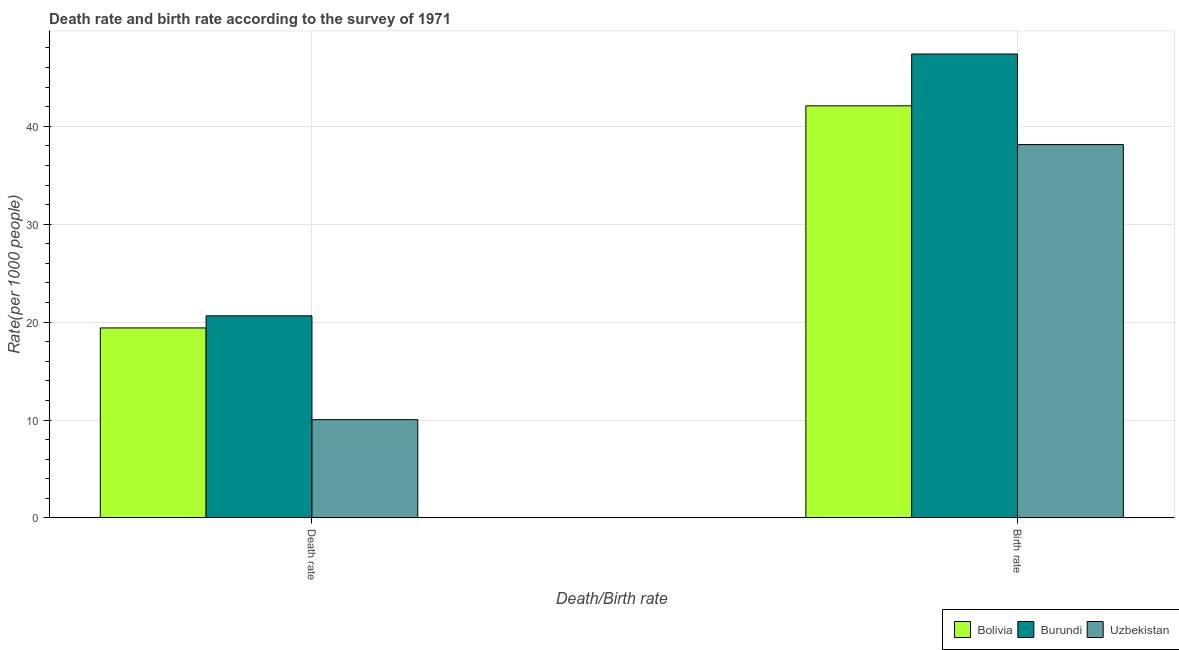Are the number of bars per tick equal to the number of legend labels?
Make the answer very short. Yes. Are the number of bars on each tick of the X-axis equal?
Your response must be concise. Yes. What is the label of the 1st group of bars from the left?
Offer a terse response. Death rate. What is the death rate in Burundi?
Give a very brief answer. 20.64. Across all countries, what is the maximum death rate?
Your response must be concise. 20.64. Across all countries, what is the minimum death rate?
Your response must be concise. 10.03. In which country was the death rate maximum?
Make the answer very short. Burundi. In which country was the birth rate minimum?
Keep it short and to the point. Uzbekistan. What is the total birth rate in the graph?
Your answer should be compact. 127.61. What is the difference between the birth rate in Bolivia and that in Burundi?
Your response must be concise. -5.29. What is the difference between the death rate in Bolivia and the birth rate in Uzbekistan?
Provide a short and direct response. -18.73. What is the average death rate per country?
Provide a short and direct response. 16.69. What is the difference between the birth rate and death rate in Burundi?
Offer a terse response. 26.74. In how many countries, is the birth rate greater than 18 ?
Offer a terse response. 3. What is the ratio of the birth rate in Uzbekistan to that in Burundi?
Provide a succinct answer. 0.8. In how many countries, is the death rate greater than the average death rate taken over all countries?
Your answer should be very brief. 2. What does the 3rd bar from the left in Birth rate represents?
Offer a terse response. Uzbekistan. What does the 1st bar from the right in Death rate represents?
Make the answer very short. Uzbekistan. How many bars are there?
Make the answer very short. 6. Are all the bars in the graph horizontal?
Offer a terse response. No. Does the graph contain grids?
Make the answer very short. Yes. Where does the legend appear in the graph?
Ensure brevity in your answer.  Bottom right. What is the title of the graph?
Give a very brief answer. Death rate and birth rate according to the survey of 1971. Does "St. Martin (French part)" appear as one of the legend labels in the graph?
Make the answer very short. No. What is the label or title of the X-axis?
Your answer should be compact. Death/Birth rate. What is the label or title of the Y-axis?
Offer a terse response. Rate(per 1000 people). What is the Rate(per 1000 people) in Bolivia in Death rate?
Your answer should be compact. 19.41. What is the Rate(per 1000 people) of Burundi in Death rate?
Keep it short and to the point. 20.64. What is the Rate(per 1000 people) in Uzbekistan in Death rate?
Keep it short and to the point. 10.03. What is the Rate(per 1000 people) of Bolivia in Birth rate?
Offer a terse response. 42.09. What is the Rate(per 1000 people) in Burundi in Birth rate?
Provide a succinct answer. 47.38. What is the Rate(per 1000 people) in Uzbekistan in Birth rate?
Offer a very short reply. 38.13. Across all Death/Birth rate, what is the maximum Rate(per 1000 people) in Bolivia?
Make the answer very short. 42.09. Across all Death/Birth rate, what is the maximum Rate(per 1000 people) in Burundi?
Ensure brevity in your answer.  47.38. Across all Death/Birth rate, what is the maximum Rate(per 1000 people) in Uzbekistan?
Your answer should be compact. 38.13. Across all Death/Birth rate, what is the minimum Rate(per 1000 people) of Bolivia?
Provide a succinct answer. 19.41. Across all Death/Birth rate, what is the minimum Rate(per 1000 people) of Burundi?
Offer a terse response. 20.64. Across all Death/Birth rate, what is the minimum Rate(per 1000 people) of Uzbekistan?
Keep it short and to the point. 10.03. What is the total Rate(per 1000 people) in Bolivia in the graph?
Ensure brevity in your answer.  61.5. What is the total Rate(per 1000 people) in Burundi in the graph?
Make the answer very short. 68.03. What is the total Rate(per 1000 people) in Uzbekistan in the graph?
Your answer should be compact. 48.16. What is the difference between the Rate(per 1000 people) of Bolivia in Death rate and that in Birth rate?
Make the answer very short. -22.69. What is the difference between the Rate(per 1000 people) in Burundi in Death rate and that in Birth rate?
Offer a very short reply. -26.74. What is the difference between the Rate(per 1000 people) of Uzbekistan in Death rate and that in Birth rate?
Your answer should be compact. -28.1. What is the difference between the Rate(per 1000 people) in Bolivia in Death rate and the Rate(per 1000 people) in Burundi in Birth rate?
Offer a terse response. -27.98. What is the difference between the Rate(per 1000 people) in Bolivia in Death rate and the Rate(per 1000 people) in Uzbekistan in Birth rate?
Offer a terse response. -18.73. What is the difference between the Rate(per 1000 people) of Burundi in Death rate and the Rate(per 1000 people) of Uzbekistan in Birth rate?
Give a very brief answer. -17.49. What is the average Rate(per 1000 people) in Bolivia per Death/Birth rate?
Provide a short and direct response. 30.75. What is the average Rate(per 1000 people) of Burundi per Death/Birth rate?
Ensure brevity in your answer.  34.01. What is the average Rate(per 1000 people) in Uzbekistan per Death/Birth rate?
Provide a short and direct response. 24.08. What is the difference between the Rate(per 1000 people) in Bolivia and Rate(per 1000 people) in Burundi in Death rate?
Offer a very short reply. -1.24. What is the difference between the Rate(per 1000 people) of Bolivia and Rate(per 1000 people) of Uzbekistan in Death rate?
Give a very brief answer. 9.37. What is the difference between the Rate(per 1000 people) of Burundi and Rate(per 1000 people) of Uzbekistan in Death rate?
Your answer should be very brief. 10.61. What is the difference between the Rate(per 1000 people) in Bolivia and Rate(per 1000 people) in Burundi in Birth rate?
Your response must be concise. -5.29. What is the difference between the Rate(per 1000 people) in Bolivia and Rate(per 1000 people) in Uzbekistan in Birth rate?
Your answer should be very brief. 3.96. What is the difference between the Rate(per 1000 people) in Burundi and Rate(per 1000 people) in Uzbekistan in Birth rate?
Offer a very short reply. 9.25. What is the ratio of the Rate(per 1000 people) in Bolivia in Death rate to that in Birth rate?
Your response must be concise. 0.46. What is the ratio of the Rate(per 1000 people) of Burundi in Death rate to that in Birth rate?
Keep it short and to the point. 0.44. What is the ratio of the Rate(per 1000 people) in Uzbekistan in Death rate to that in Birth rate?
Your answer should be compact. 0.26. What is the difference between the highest and the second highest Rate(per 1000 people) of Bolivia?
Provide a short and direct response. 22.69. What is the difference between the highest and the second highest Rate(per 1000 people) in Burundi?
Give a very brief answer. 26.74. What is the difference between the highest and the second highest Rate(per 1000 people) of Uzbekistan?
Offer a terse response. 28.1. What is the difference between the highest and the lowest Rate(per 1000 people) in Bolivia?
Your answer should be compact. 22.69. What is the difference between the highest and the lowest Rate(per 1000 people) of Burundi?
Make the answer very short. 26.74. What is the difference between the highest and the lowest Rate(per 1000 people) of Uzbekistan?
Provide a succinct answer. 28.1. 